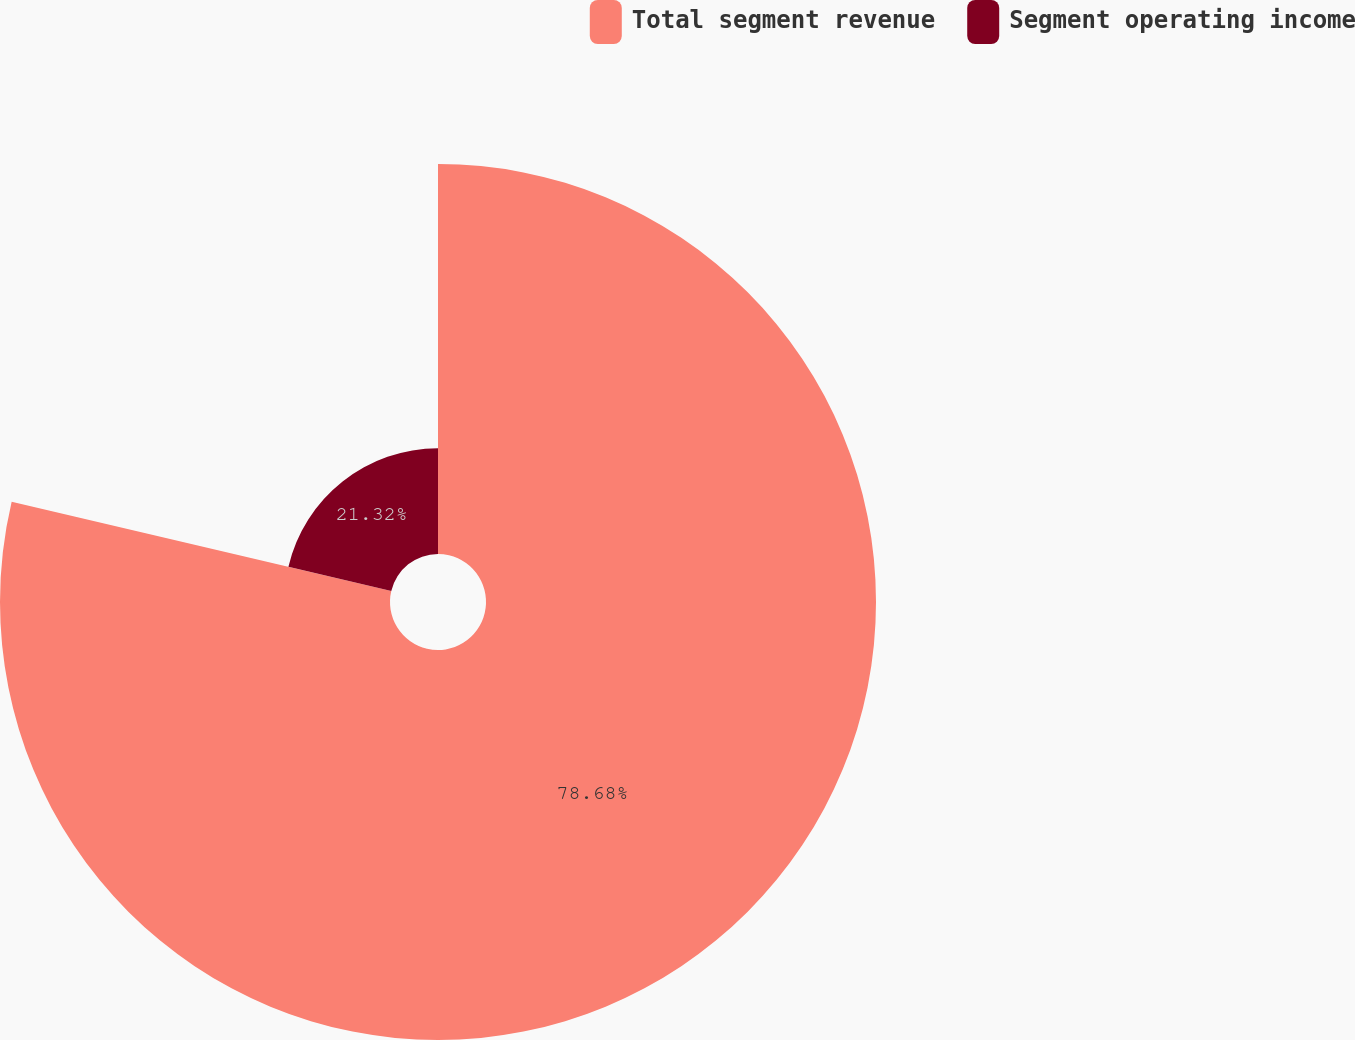<chart> <loc_0><loc_0><loc_500><loc_500><pie_chart><fcel>Total segment revenue<fcel>Segment operating income<nl><fcel>78.68%<fcel>21.32%<nl></chart> 